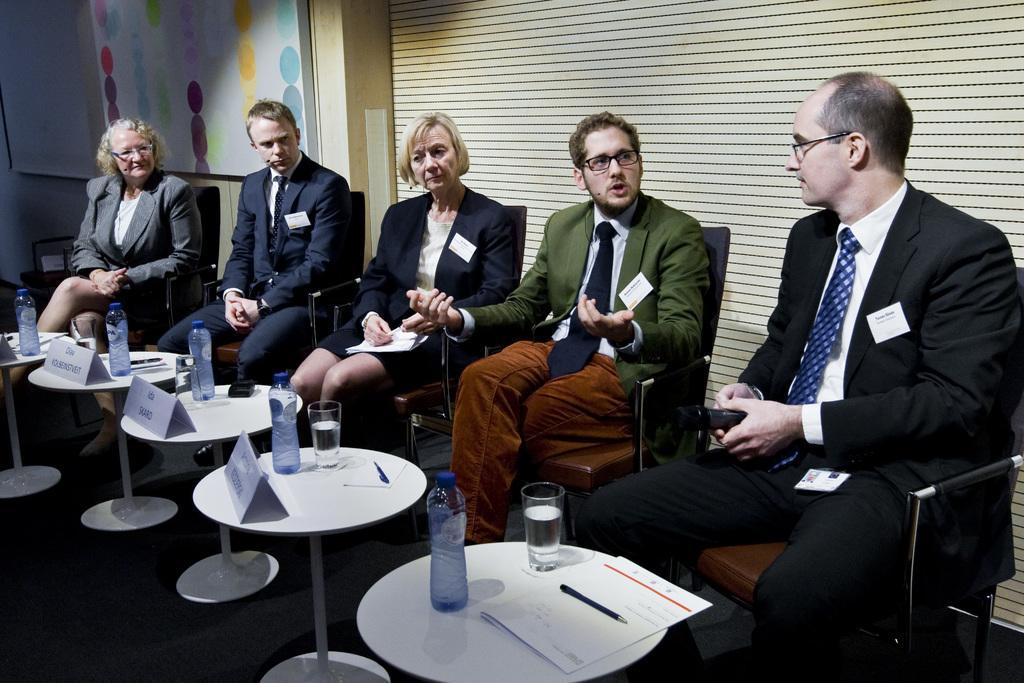Can you describe this image briefly? The image is taken inside a room. There are five people sitting on a chair. There is a table. There is a bottle, glass, pen and a paper placed on a table. In the background there is a board. The person with the green suit is talking. 